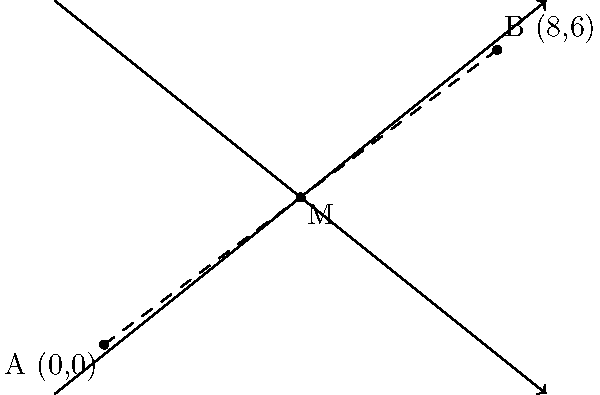In a pharmacy floor plan, two safety showers are located at coordinates A(0,0) and B(8,6). To optimize the placement of a new emergency eye wash station, you need to find the midpoint between these two safety shower locations. What are the coordinates of the midpoint M? To find the midpoint M between two points A(x₁, y₁) and B(x₂, y₂), we use the midpoint formula:

$$ M = (\frac{x_1 + x_2}{2}, \frac{y_1 + y_2}{2}) $$

Given:
- Point A: (0, 0)
- Point B: (8, 6)

Step 1: Calculate the x-coordinate of the midpoint:
$$ x_M = \frac{x_1 + x_2}{2} = \frac{0 + 8}{2} = \frac{8}{2} = 4 $$

Step 2: Calculate the y-coordinate of the midpoint:
$$ y_M = \frac{y_1 + y_2}{2} = \frac{0 + 6}{2} = \frac{6}{2} = 3 $$

Therefore, the coordinates of the midpoint M are (4, 3).
Answer: (4, 3) 